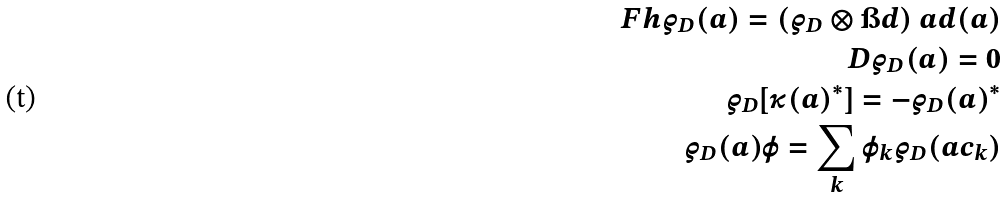Convert formula to latex. <formula><loc_0><loc_0><loc_500><loc_500>\ F h \varrho _ { D } ( a ) = ( \varrho _ { D } \otimes \i d ) \ a d ( a ) \\ D \varrho _ { D } ( a ) = 0 \\ \varrho _ { D } [ \kappa ( a ) ^ { * } ] = - \varrho _ { D } ( a ) ^ { * } \\ \varrho _ { D } ( a ) \varphi = \sum _ { k } \varphi _ { k } \varrho _ { D } ( a c _ { k } )</formula> 